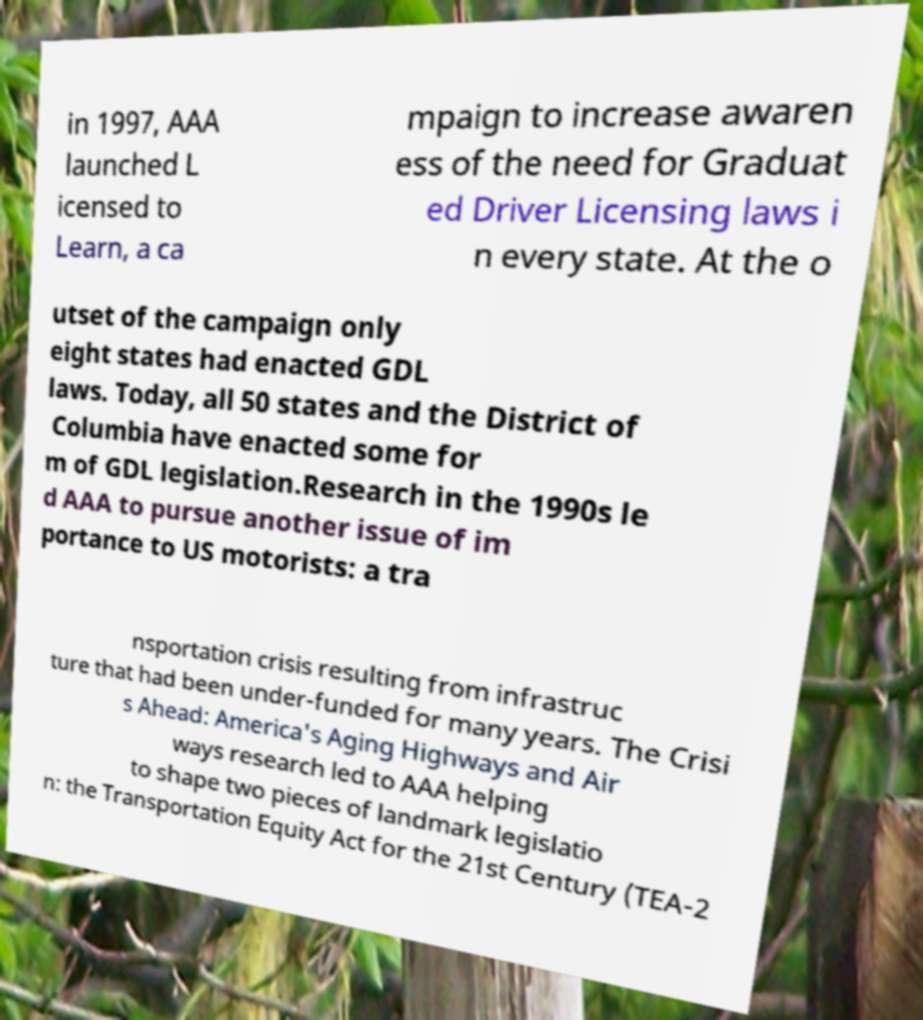There's text embedded in this image that I need extracted. Can you transcribe it verbatim? in 1997, AAA launched L icensed to Learn, a ca mpaign to increase awaren ess of the need for Graduat ed Driver Licensing laws i n every state. At the o utset of the campaign only eight states had enacted GDL laws. Today, all 50 states and the District of Columbia have enacted some for m of GDL legislation.Research in the 1990s le d AAA to pursue another issue of im portance to US motorists: a tra nsportation crisis resulting from infrastruc ture that had been under-funded for many years. The Crisi s Ahead: America's Aging Highways and Air ways research led to AAA helping to shape two pieces of landmark legislatio n: the Transportation Equity Act for the 21st Century (TEA-2 